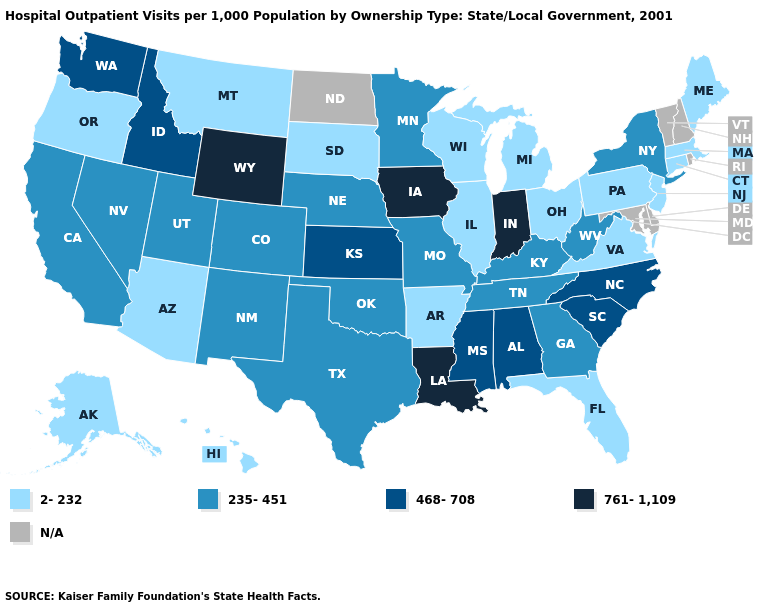Name the states that have a value in the range 468-708?
Short answer required. Alabama, Idaho, Kansas, Mississippi, North Carolina, South Carolina, Washington. Which states hav the highest value in the South?
Keep it brief. Louisiana. Which states have the highest value in the USA?
Give a very brief answer. Indiana, Iowa, Louisiana, Wyoming. What is the value of Mississippi?
Answer briefly. 468-708. What is the value of Illinois?
Concise answer only. 2-232. What is the value of Connecticut?
Write a very short answer. 2-232. What is the highest value in the USA?
Quick response, please. 761-1,109. What is the value of Oklahoma?
Be succinct. 235-451. What is the value of Louisiana?
Be succinct. 761-1,109. Which states have the lowest value in the USA?
Write a very short answer. Alaska, Arizona, Arkansas, Connecticut, Florida, Hawaii, Illinois, Maine, Massachusetts, Michigan, Montana, New Jersey, Ohio, Oregon, Pennsylvania, South Dakota, Virginia, Wisconsin. What is the value of Alaska?
Answer briefly. 2-232. Name the states that have a value in the range 235-451?
Be succinct. California, Colorado, Georgia, Kentucky, Minnesota, Missouri, Nebraska, Nevada, New Mexico, New York, Oklahoma, Tennessee, Texas, Utah, West Virginia. Name the states that have a value in the range 761-1,109?
Short answer required. Indiana, Iowa, Louisiana, Wyoming. What is the value of South Dakota?
Be succinct. 2-232. 